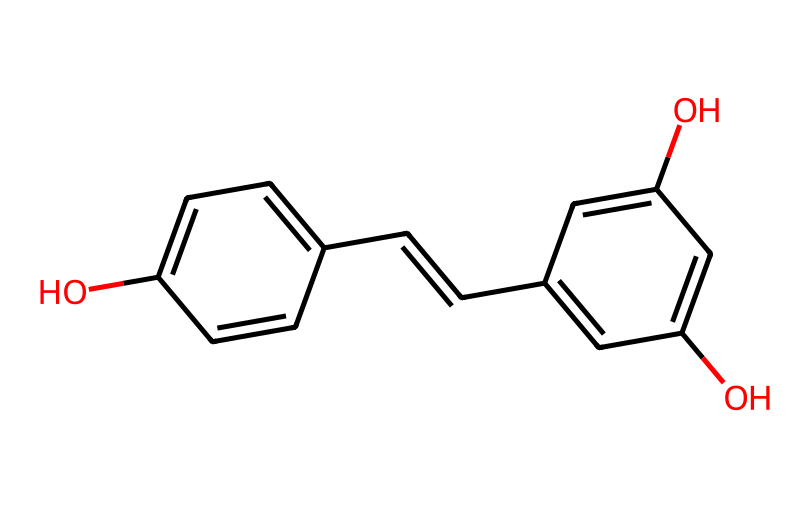What is the chemical name of the compound represented? The SMILES notation suggests a compound with hydroxyl groups and a specific arrangement of carbon-carbon double bonds. This corresponds to resveratrol, which is a polyphenolic compound.
Answer: resveratrol How many hydroxyl (–OH) groups are present in the compound? Looking at the displayed chemical structure, there are three –OH groups indicated, one on each aromatic ring.
Answer: three How many carbon atoms are in the structure of resveratrol? To determine this, count all the carbon atoms in the structure, including those in the double bonds. The compound has 14 carbon atoms.
Answer: fourteen What type of compounds does resveratrol belong to? Based on its structure, which includes multiple aromatic rings and hydroxyl groups, resveratrol is classified as a polyphenol.
Answer: polyphenol How many rings are present in the structure? By examining the structure visually, there are two aromatic rings, which are the hallmark features of aromatic compounds.
Answer: two Can this compound act as an antioxidant? The presence of hydroxyl groups in resveratrol allows it to donate electrons, enabling it to neutralize free radicals, thus acting as an antioxidant.
Answer: yes What type of bond connects the two aromatic rings? The presence of a double bond (C=C) between the two aromatic rings indicates that they are connected through a carbon-carbon double bond.
Answer: double bond 